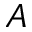Convert formula to latex. <formula><loc_0><loc_0><loc_500><loc_500>A</formula> 